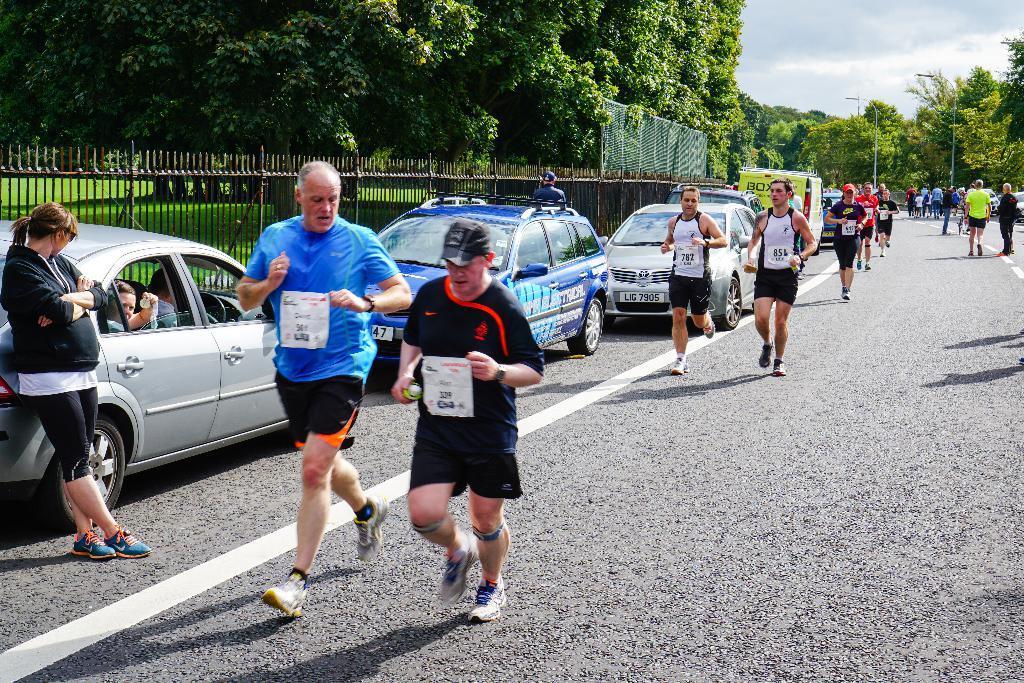In one or two sentences, can you explain what this image depicts? In this picture we can observe some people running on the road. We can observe some cars on the left side of the road. There is a black color railing and some trees. In the background there is a sky. 